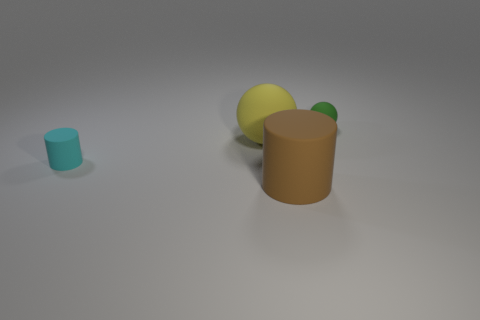Add 2 large yellow balls. How many objects exist? 6 Subtract all large purple shiny cylinders. Subtract all large matte things. How many objects are left? 2 Add 2 brown objects. How many brown objects are left? 3 Add 1 small matte objects. How many small matte objects exist? 3 Subtract 0 blue spheres. How many objects are left? 4 